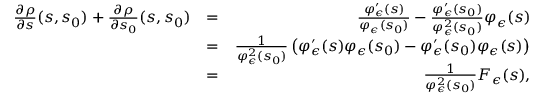<formula> <loc_0><loc_0><loc_500><loc_500>\begin{array} { r l r } { \frac { \partial \rho } { \partial s } ( s , s _ { 0 } ) + \frac { \partial \rho } { \partial s _ { 0 } } ( s , s _ { 0 } ) } & { = } & { \frac { \varphi _ { \epsilon } ^ { \prime } ( s ) } { \varphi _ { \epsilon } ( s _ { 0 } ) } - \frac { \varphi _ { \epsilon } ^ { \prime } ( s _ { 0 } ) } { \varphi _ { \epsilon } ^ { 2 } ( s _ { 0 } ) } \varphi _ { \epsilon } ( s ) } \\ & { = } & { \frac { 1 } { \varphi _ { \epsilon } ^ { 2 } ( s _ { 0 } ) } \left ( \varphi _ { \epsilon } ^ { \prime } ( s ) \varphi _ { \epsilon } ( s _ { 0 } ) - \varphi _ { \epsilon } ^ { \prime } ( s _ { 0 } ) \varphi _ { \epsilon } ( s ) \right ) } \\ & { = } & { \frac { 1 } { \varphi _ { \epsilon } ^ { 2 } ( s _ { 0 } ) } F _ { \epsilon } ( s ) , } \end{array}</formula> 